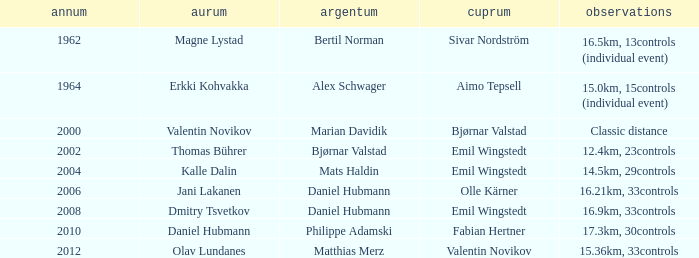WHAT YEAR HAS A SILVER FOR MATTHIAS MERZ? 2012.0. 